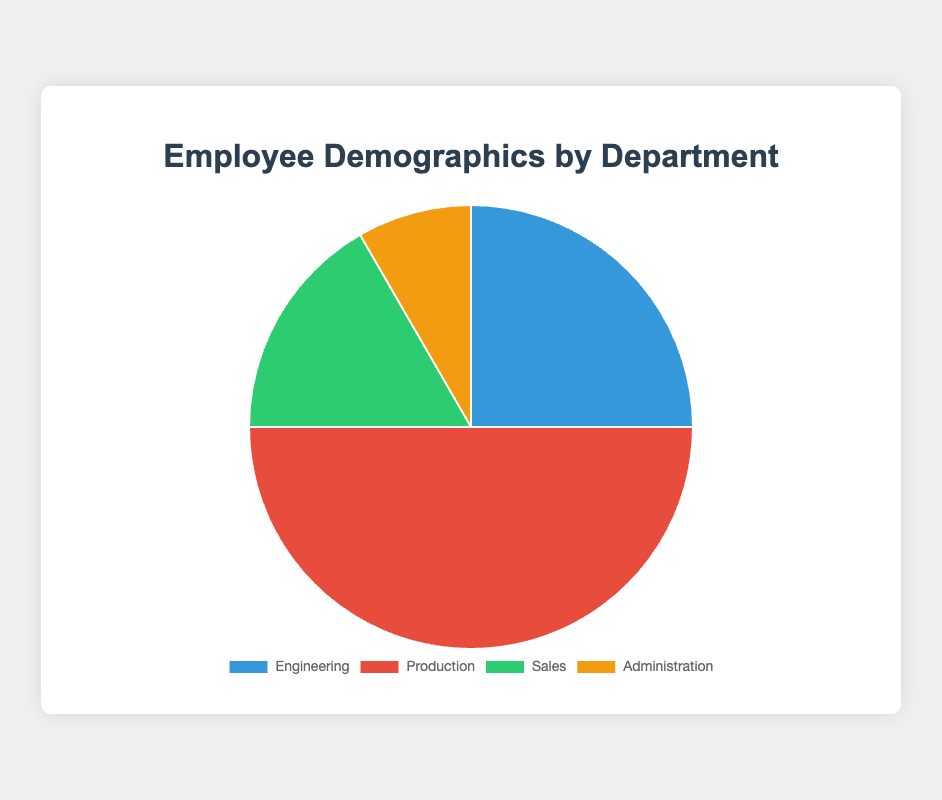What is the largest department in terms of total employees? By looking at the pie chart, the department with the largest slice represents the largest number of employees. The largest slice is labeled 'Production,' which means Production has the most employees.
Answer: Production Which department has fewer employees: Engineering or Sales? In the pie chart, compare the sizes of the slices for Engineering and Sales. The Engineering slice is larger than the Sales slice. Therefore, Sales has fewer employees.
Answer: Sales What is the combined total number of employees in Engineering and Administration? Engineering has 150 employees and Administration has 50 employees. Adding these gives 150 + 50 = 200 employees in total.
Answer: 200 Which department has twice as many employees as Administration? Administration has 50 employees. Checking the chart, the Sales department has 100 employees, which is exactly twice the number of Administration employees.
Answer: Sales What is the percentage of employees in the Production department? The total number of employees across all departments is 150 (Engineering) + 300 (Production) + 100 (Sales) + 50 (Administration) = 600. The percentage in Production is (300 / 600) * 100 = 50%.
Answer: 50% How much larger is the Production department compared to Engineering in terms of employees? Production has 300 employees while Engineering has 150 employees. The difference is 300 - 150 = 150 employees.
Answer: 150 Which department has the smallest number of employees? Looking at the pie chart, the smallest slice corresponds to the Administration department.
Answer: Administration If 50 more employees were added to Engineering, how many total employees would the company have? Currently, there are 150 (Engineering) + 300 (Production) + 100 (Sales) + 50 (Administration) = 600 employees. Adding 50 employees to Engineering: 600 + 50 = 650 total employees.
Answer: 650 Which departments combined have exactly as many employees as Production? Engineering has 150 employees, Sales has 100 employees, and Administration has 50 employees. Summing these gives 150 + 100 + 50 = 300 employees, which equals the number of employees in Production.
Answer: Engineering, Sales, Administration What is the average number of employees per department? The total number of employees is 600, distributed over 4 departments. The average is 600 / 4 = 150 employees per department.
Answer: 150 